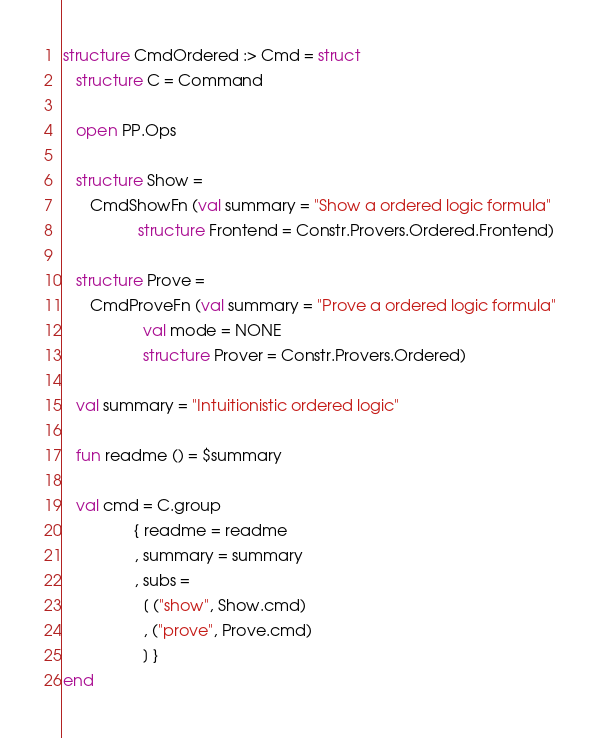<code> <loc_0><loc_0><loc_500><loc_500><_SML_>
structure CmdOrdered :> Cmd = struct
   structure C = Command

   open PP.Ops

   structure Show =
      CmdShowFn (val summary = "Show a ordered logic formula"
                 structure Frontend = Constr.Provers.Ordered.Frontend)

   structure Prove =
      CmdProveFn (val summary = "Prove a ordered logic formula"
                  val mode = NONE
                  structure Prover = Constr.Provers.Ordered)

   val summary = "Intuitionistic ordered logic"

   fun readme () = $summary

   val cmd = C.group
                { readme = readme
                , summary = summary
                , subs =
                  [ ("show", Show.cmd)
                  , ("prove", Prove.cmd)
                  ] }
end
</code> 